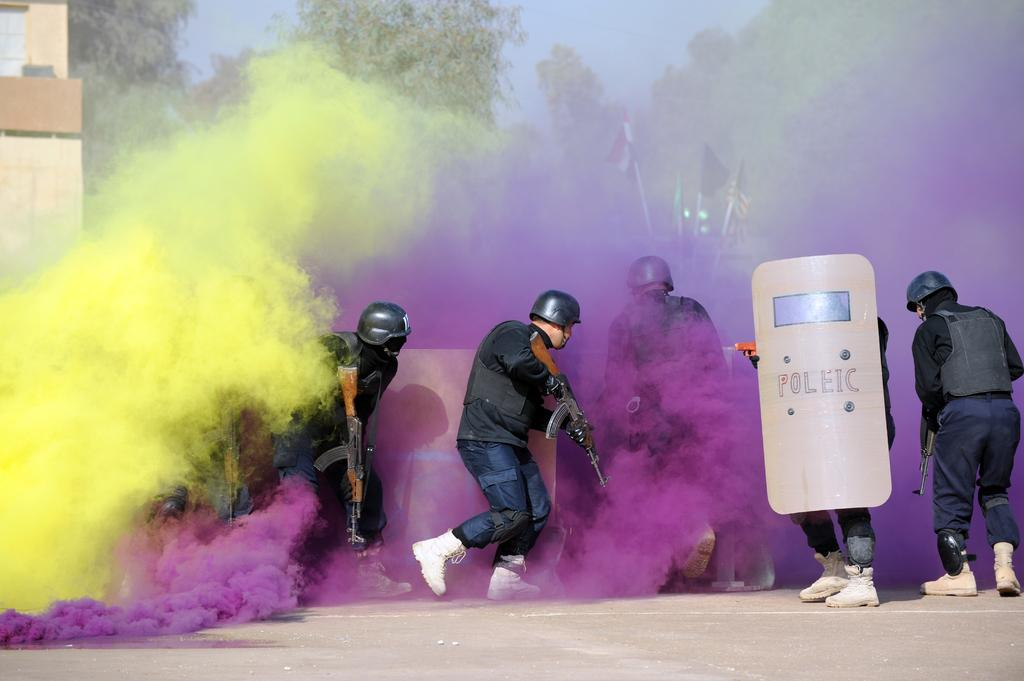What are the people in the image holding? The people in the image are holding guns and sheets. Where are the people standing in the image? The people are standing on a road. What can be seen in the background of the image? There are trees, flags, buildings, and the sky visible in the background of the image. What type of shirt is the ant wearing in the image? There is no ant present in the image, and therefore no shirt or any other clothing item can be observed. 